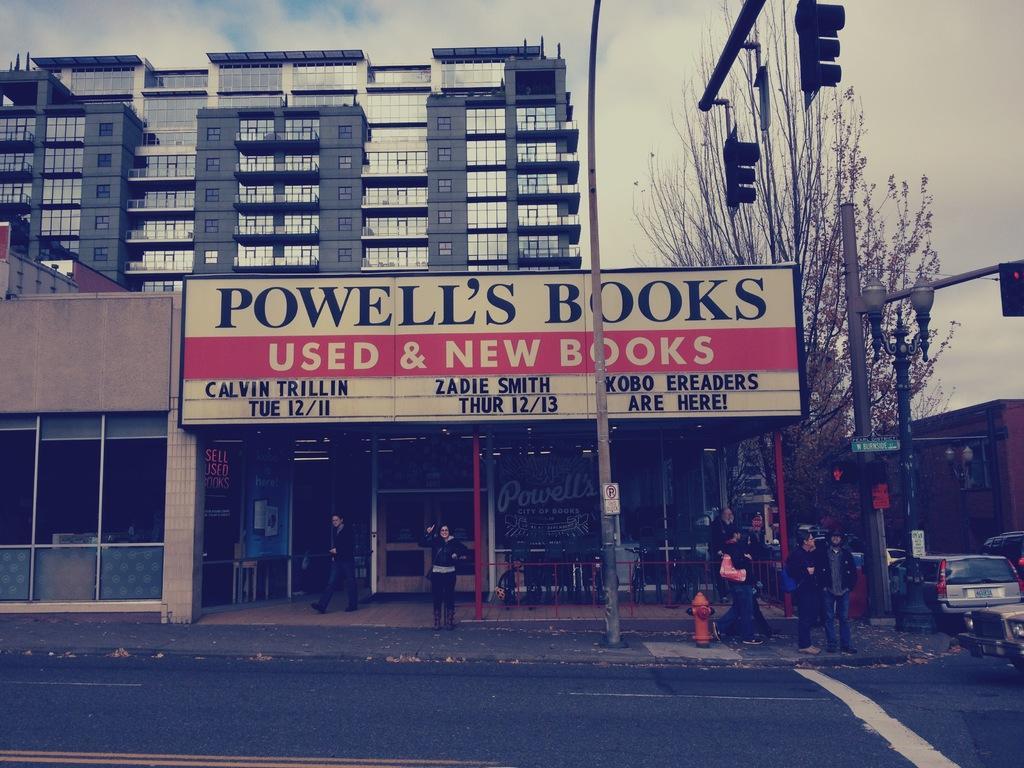How would you summarize this image in a sentence or two? This is the picture of a place where we have some buildings to which there are some glass windows and there is a shop to which there is a board and we can see some people, pole which has some traffic lights and a tree. 